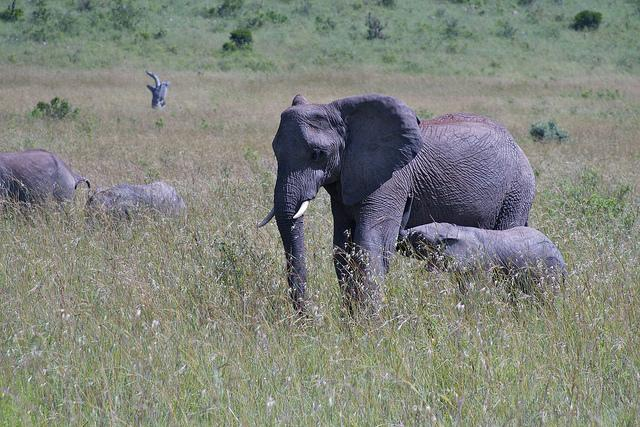What is the sharpest item here?

Choices:
A) scissors
B) unicorn horn
C) tusks
D) machete tusks 